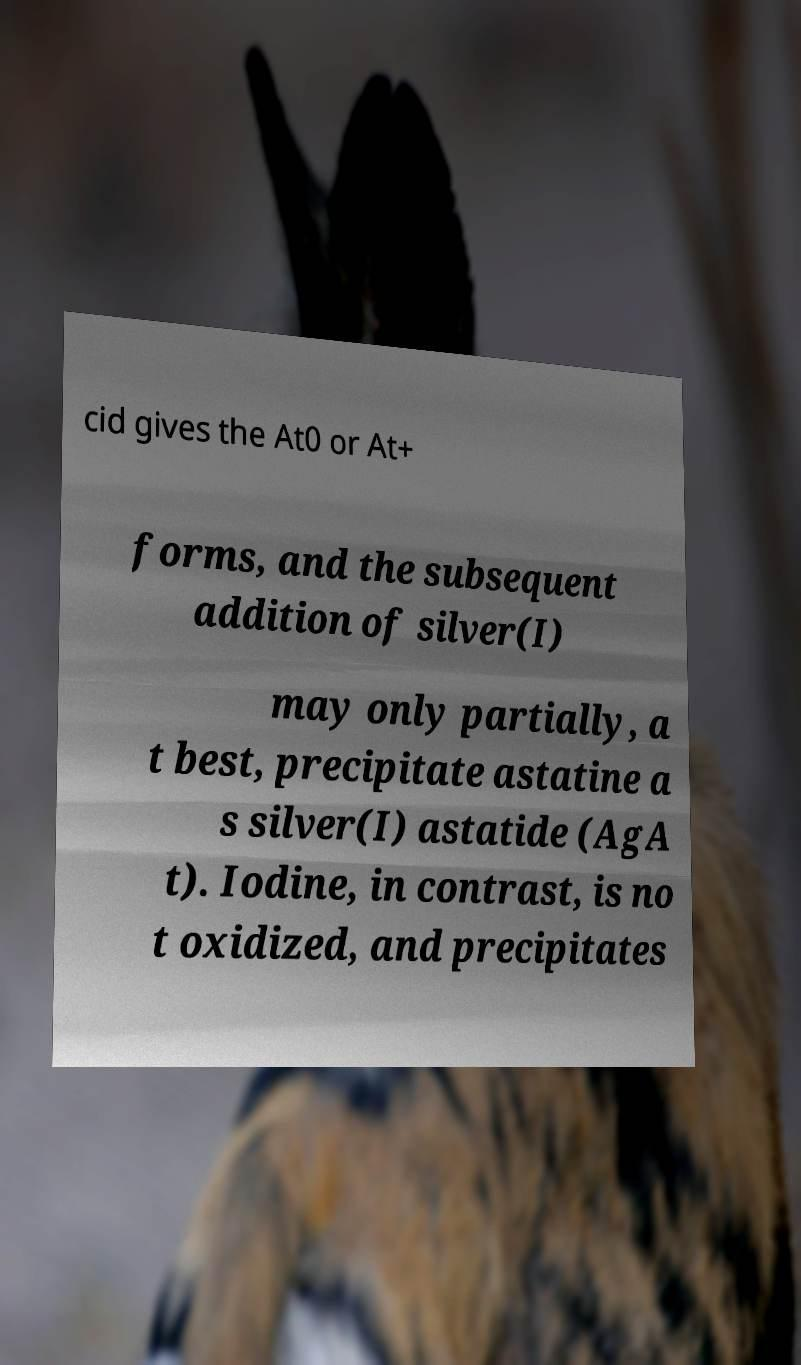Can you read and provide the text displayed in the image?This photo seems to have some interesting text. Can you extract and type it out for me? cid gives the At0 or At+ forms, and the subsequent addition of silver(I) may only partially, a t best, precipitate astatine a s silver(I) astatide (AgA t). Iodine, in contrast, is no t oxidized, and precipitates 